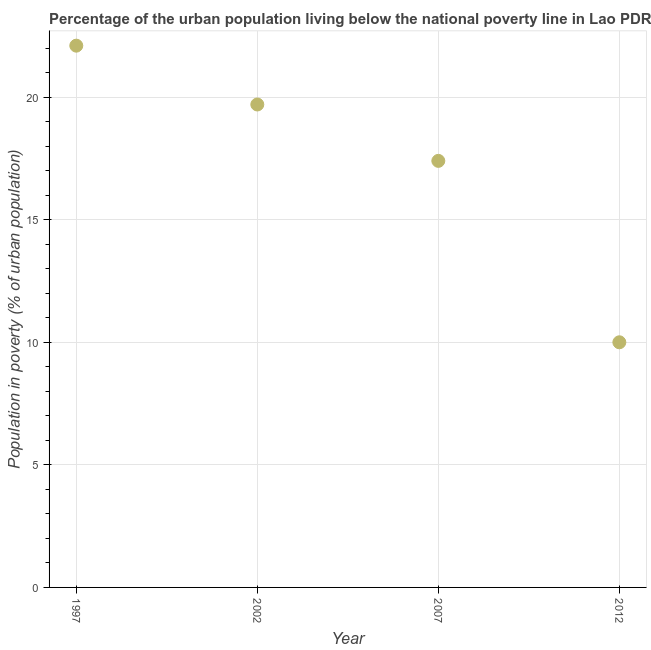Across all years, what is the maximum percentage of urban population living below poverty line?
Make the answer very short. 22.1. Across all years, what is the minimum percentage of urban population living below poverty line?
Make the answer very short. 10. In which year was the percentage of urban population living below poverty line maximum?
Ensure brevity in your answer.  1997. What is the sum of the percentage of urban population living below poverty line?
Your response must be concise. 69.2. What is the difference between the percentage of urban population living below poverty line in 2002 and 2007?
Make the answer very short. 2.3. What is the average percentage of urban population living below poverty line per year?
Your answer should be compact. 17.3. What is the median percentage of urban population living below poverty line?
Your answer should be compact. 18.55. In how many years, is the percentage of urban population living below poverty line greater than 6 %?
Provide a short and direct response. 4. What is the ratio of the percentage of urban population living below poverty line in 2002 to that in 2012?
Your response must be concise. 1.97. Is the difference between the percentage of urban population living below poverty line in 2007 and 2012 greater than the difference between any two years?
Offer a very short reply. No. What is the difference between the highest and the second highest percentage of urban population living below poverty line?
Your response must be concise. 2.4. What is the difference between the highest and the lowest percentage of urban population living below poverty line?
Offer a very short reply. 12.1. In how many years, is the percentage of urban population living below poverty line greater than the average percentage of urban population living below poverty line taken over all years?
Offer a very short reply. 3. Does the percentage of urban population living below poverty line monotonically increase over the years?
Make the answer very short. No. How many dotlines are there?
Keep it short and to the point. 1. How many years are there in the graph?
Offer a terse response. 4. What is the difference between two consecutive major ticks on the Y-axis?
Provide a succinct answer. 5. Are the values on the major ticks of Y-axis written in scientific E-notation?
Give a very brief answer. No. What is the title of the graph?
Give a very brief answer. Percentage of the urban population living below the national poverty line in Lao PDR. What is the label or title of the X-axis?
Keep it short and to the point. Year. What is the label or title of the Y-axis?
Ensure brevity in your answer.  Population in poverty (% of urban population). What is the Population in poverty (% of urban population) in 1997?
Your answer should be very brief. 22.1. What is the difference between the Population in poverty (% of urban population) in 2002 and 2007?
Your answer should be very brief. 2.3. What is the difference between the Population in poverty (% of urban population) in 2007 and 2012?
Ensure brevity in your answer.  7.4. What is the ratio of the Population in poverty (% of urban population) in 1997 to that in 2002?
Your answer should be compact. 1.12. What is the ratio of the Population in poverty (% of urban population) in 1997 to that in 2007?
Your answer should be compact. 1.27. What is the ratio of the Population in poverty (% of urban population) in 1997 to that in 2012?
Provide a succinct answer. 2.21. What is the ratio of the Population in poverty (% of urban population) in 2002 to that in 2007?
Make the answer very short. 1.13. What is the ratio of the Population in poverty (% of urban population) in 2002 to that in 2012?
Provide a succinct answer. 1.97. What is the ratio of the Population in poverty (% of urban population) in 2007 to that in 2012?
Your response must be concise. 1.74. 